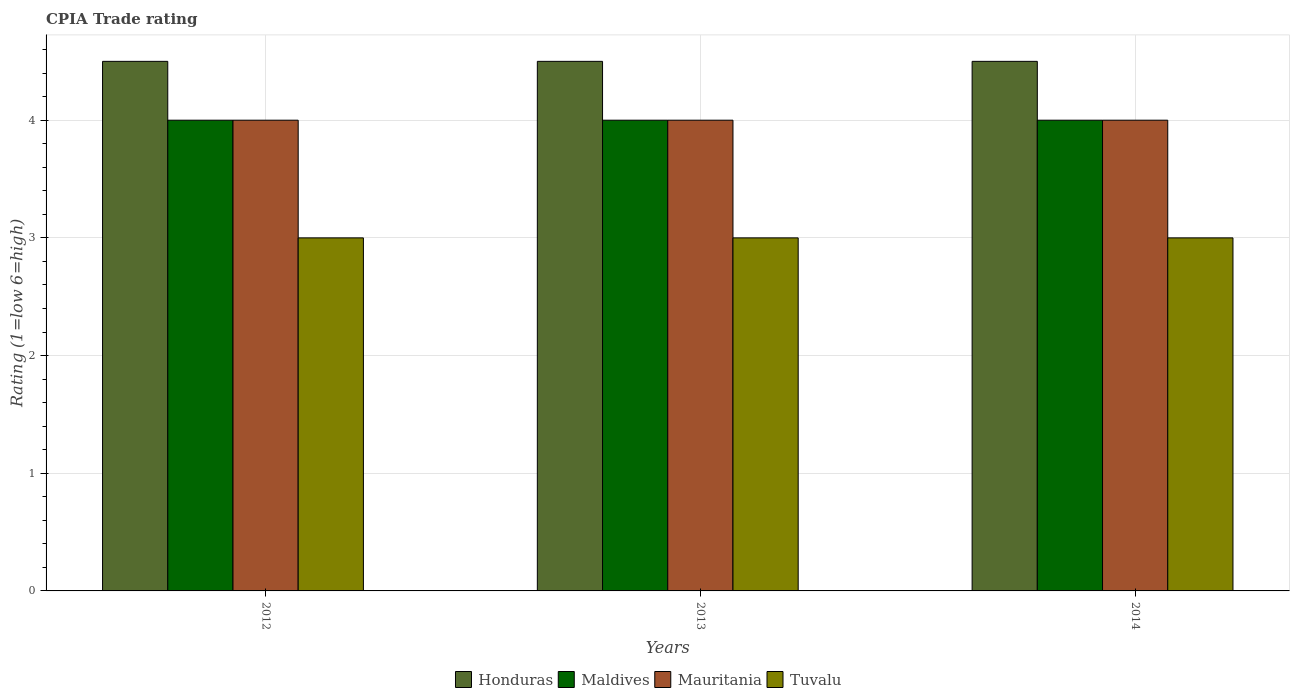How many groups of bars are there?
Provide a succinct answer. 3. Are the number of bars on each tick of the X-axis equal?
Give a very brief answer. Yes. How many bars are there on the 3rd tick from the right?
Offer a terse response. 4. What is the label of the 3rd group of bars from the left?
Your answer should be compact. 2014. What is the CPIA rating in Maldives in 2012?
Offer a very short reply. 4. Across all years, what is the minimum CPIA rating in Honduras?
Make the answer very short. 4.5. In which year was the CPIA rating in Honduras maximum?
Offer a very short reply. 2012. What is the total CPIA rating in Maldives in the graph?
Offer a very short reply. 12. What is the difference between the CPIA rating in Maldives in 2014 and the CPIA rating in Honduras in 2012?
Offer a terse response. -0.5. In the year 2012, what is the difference between the CPIA rating in Mauritania and CPIA rating in Maldives?
Your answer should be very brief. 0. Is the CPIA rating in Mauritania in 2012 less than that in 2014?
Offer a terse response. No. What is the difference between the highest and the second highest CPIA rating in Mauritania?
Make the answer very short. 0. Is the sum of the CPIA rating in Tuvalu in 2012 and 2013 greater than the maximum CPIA rating in Maldives across all years?
Provide a short and direct response. Yes. Is it the case that in every year, the sum of the CPIA rating in Mauritania and CPIA rating in Maldives is greater than the sum of CPIA rating in Honduras and CPIA rating in Tuvalu?
Provide a succinct answer. No. What does the 4th bar from the left in 2013 represents?
Provide a succinct answer. Tuvalu. What does the 2nd bar from the right in 2012 represents?
Your answer should be compact. Mauritania. Is it the case that in every year, the sum of the CPIA rating in Tuvalu and CPIA rating in Honduras is greater than the CPIA rating in Maldives?
Your response must be concise. Yes. How many years are there in the graph?
Your answer should be compact. 3. What is the difference between two consecutive major ticks on the Y-axis?
Make the answer very short. 1. Are the values on the major ticks of Y-axis written in scientific E-notation?
Offer a terse response. No. Does the graph contain any zero values?
Your answer should be very brief. No. How many legend labels are there?
Offer a terse response. 4. What is the title of the graph?
Make the answer very short. CPIA Trade rating. What is the label or title of the X-axis?
Your answer should be very brief. Years. What is the Rating (1=low 6=high) of Honduras in 2012?
Your answer should be very brief. 4.5. What is the Rating (1=low 6=high) in Mauritania in 2012?
Keep it short and to the point. 4. What is the Rating (1=low 6=high) in Honduras in 2013?
Make the answer very short. 4.5. What is the Rating (1=low 6=high) of Tuvalu in 2013?
Ensure brevity in your answer.  3. What is the Rating (1=low 6=high) of Maldives in 2014?
Offer a very short reply. 4. What is the Rating (1=low 6=high) of Mauritania in 2014?
Your answer should be very brief. 4. Across all years, what is the maximum Rating (1=low 6=high) in Maldives?
Your answer should be compact. 4. Across all years, what is the maximum Rating (1=low 6=high) of Mauritania?
Ensure brevity in your answer.  4. Across all years, what is the minimum Rating (1=low 6=high) of Maldives?
Keep it short and to the point. 4. Across all years, what is the minimum Rating (1=low 6=high) of Tuvalu?
Give a very brief answer. 3. What is the total Rating (1=low 6=high) of Tuvalu in the graph?
Keep it short and to the point. 9. What is the difference between the Rating (1=low 6=high) of Maldives in 2012 and that in 2013?
Give a very brief answer. 0. What is the difference between the Rating (1=low 6=high) in Tuvalu in 2012 and that in 2014?
Offer a very short reply. 0. What is the difference between the Rating (1=low 6=high) of Honduras in 2013 and that in 2014?
Offer a terse response. 0. What is the difference between the Rating (1=low 6=high) in Maldives in 2013 and that in 2014?
Provide a succinct answer. 0. What is the difference between the Rating (1=low 6=high) of Tuvalu in 2013 and that in 2014?
Give a very brief answer. 0. What is the difference between the Rating (1=low 6=high) in Honduras in 2012 and the Rating (1=low 6=high) in Mauritania in 2013?
Give a very brief answer. 0.5. What is the difference between the Rating (1=low 6=high) of Honduras in 2012 and the Rating (1=low 6=high) of Tuvalu in 2013?
Make the answer very short. 1.5. What is the difference between the Rating (1=low 6=high) in Maldives in 2012 and the Rating (1=low 6=high) in Mauritania in 2013?
Make the answer very short. 0. What is the difference between the Rating (1=low 6=high) of Mauritania in 2012 and the Rating (1=low 6=high) of Tuvalu in 2013?
Offer a terse response. 1. What is the difference between the Rating (1=low 6=high) of Maldives in 2012 and the Rating (1=low 6=high) of Mauritania in 2014?
Offer a terse response. 0. What is the difference between the Rating (1=low 6=high) of Honduras in 2013 and the Rating (1=low 6=high) of Mauritania in 2014?
Your answer should be very brief. 0.5. What is the difference between the Rating (1=low 6=high) in Maldives in 2013 and the Rating (1=low 6=high) in Tuvalu in 2014?
Give a very brief answer. 1. What is the average Rating (1=low 6=high) of Maldives per year?
Your response must be concise. 4. What is the average Rating (1=low 6=high) in Tuvalu per year?
Ensure brevity in your answer.  3. In the year 2012, what is the difference between the Rating (1=low 6=high) in Honduras and Rating (1=low 6=high) in Mauritania?
Offer a very short reply. 0.5. In the year 2012, what is the difference between the Rating (1=low 6=high) of Honduras and Rating (1=low 6=high) of Tuvalu?
Provide a succinct answer. 1.5. In the year 2012, what is the difference between the Rating (1=low 6=high) of Maldives and Rating (1=low 6=high) of Mauritania?
Keep it short and to the point. 0. In the year 2012, what is the difference between the Rating (1=low 6=high) of Mauritania and Rating (1=low 6=high) of Tuvalu?
Your answer should be very brief. 1. In the year 2013, what is the difference between the Rating (1=low 6=high) of Honduras and Rating (1=low 6=high) of Maldives?
Give a very brief answer. 0.5. In the year 2013, what is the difference between the Rating (1=low 6=high) of Honduras and Rating (1=low 6=high) of Mauritania?
Offer a very short reply. 0.5. In the year 2014, what is the difference between the Rating (1=low 6=high) of Honduras and Rating (1=low 6=high) of Mauritania?
Give a very brief answer. 0.5. In the year 2014, what is the difference between the Rating (1=low 6=high) in Maldives and Rating (1=low 6=high) in Mauritania?
Give a very brief answer. 0. In the year 2014, what is the difference between the Rating (1=low 6=high) in Mauritania and Rating (1=low 6=high) in Tuvalu?
Provide a short and direct response. 1. What is the ratio of the Rating (1=low 6=high) of Honduras in 2012 to that in 2013?
Your answer should be very brief. 1. What is the ratio of the Rating (1=low 6=high) of Maldives in 2012 to that in 2013?
Make the answer very short. 1. What is the ratio of the Rating (1=low 6=high) of Mauritania in 2012 to that in 2013?
Your answer should be compact. 1. What is the ratio of the Rating (1=low 6=high) in Tuvalu in 2012 to that in 2013?
Offer a terse response. 1. What is the ratio of the Rating (1=low 6=high) of Maldives in 2012 to that in 2014?
Give a very brief answer. 1. What is the ratio of the Rating (1=low 6=high) in Honduras in 2013 to that in 2014?
Your answer should be very brief. 1. What is the ratio of the Rating (1=low 6=high) in Maldives in 2013 to that in 2014?
Keep it short and to the point. 1. What is the difference between the highest and the second highest Rating (1=low 6=high) in Honduras?
Make the answer very short. 0. What is the difference between the highest and the lowest Rating (1=low 6=high) in Honduras?
Provide a short and direct response. 0. What is the difference between the highest and the lowest Rating (1=low 6=high) in Maldives?
Make the answer very short. 0. What is the difference between the highest and the lowest Rating (1=low 6=high) in Tuvalu?
Offer a very short reply. 0. 